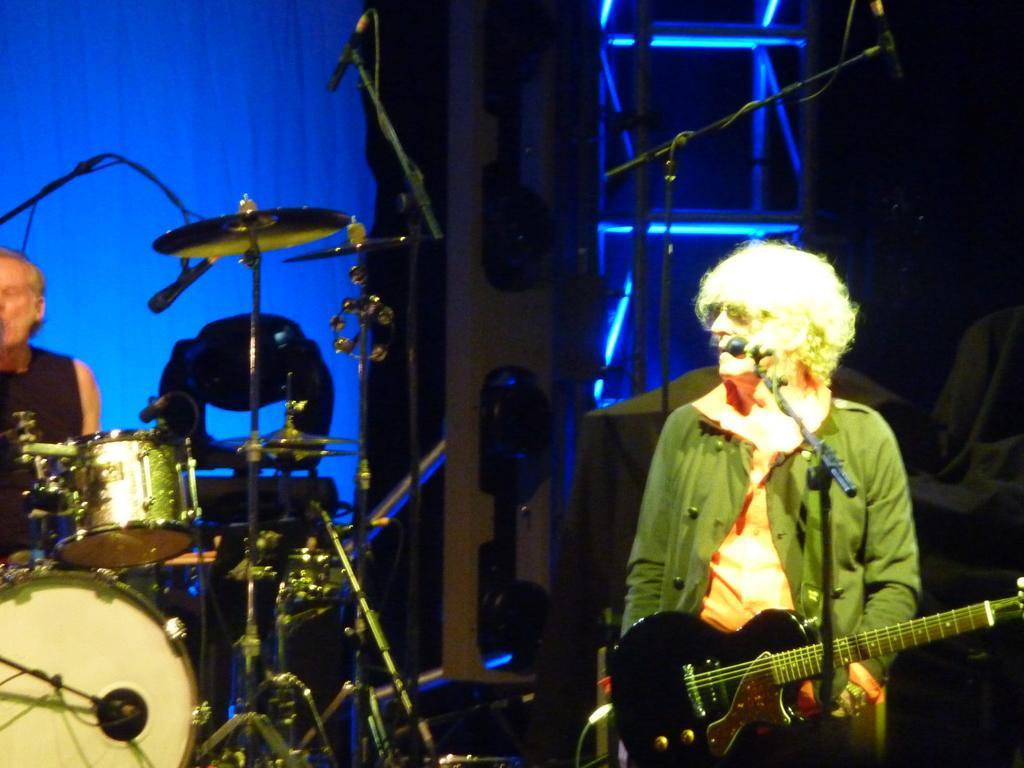Could you give a brief overview of what you see in this image? In this picture a woman is standing near the microphone holding a guitar and a person who is sitting at the drum set is holding a micro phone 